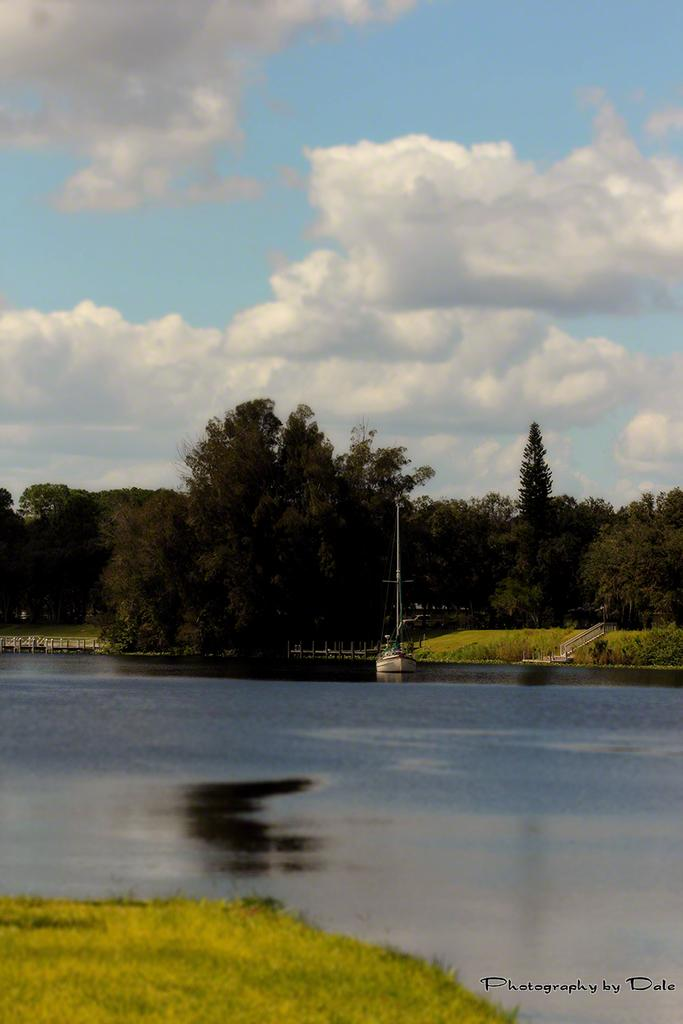What is the main subject of the image? The main subject of the image is a boat. Where is the boat located? The boat is in a large water body. What type of vegetation can be seen in the image? There is grass, plants, and a group of trees visible in the image. What else is present in the image besides the boat and vegetation? There is a pole in the image. What can be seen in the sky in the image? The sky is visible in the image. What type of jewel can be seen on the stove in the image? There is no stove or jewel present in the image. What thing is the boat using to move in the image? The boat does not appear to be moving in the image, and there is no visible means of propulsion. 